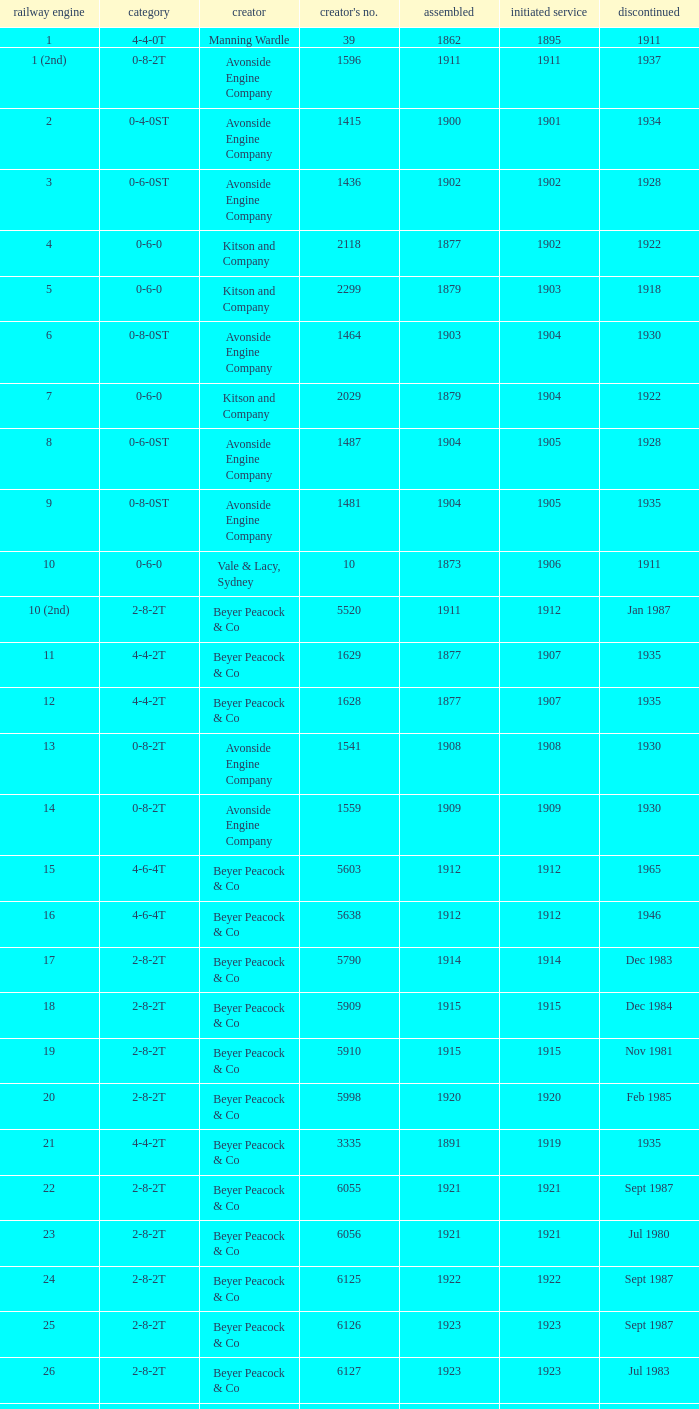How many years entered service when there were 13 locomotives? 1.0. Could you help me parse every detail presented in this table? {'header': ['railway engine', 'category', 'creator', "creator's no.", 'assembled', 'initiated service', 'discontinued'], 'rows': [['1', '4-4-0T', 'Manning Wardle', '39', '1862', '1895', '1911'], ['1 (2nd)', '0-8-2T', 'Avonside Engine Company', '1596', '1911', '1911', '1937'], ['2', '0-4-0ST', 'Avonside Engine Company', '1415', '1900', '1901', '1934'], ['3', '0-6-0ST', 'Avonside Engine Company', '1436', '1902', '1902', '1928'], ['4', '0-6-0', 'Kitson and Company', '2118', '1877', '1902', '1922'], ['5', '0-6-0', 'Kitson and Company', '2299', '1879', '1903', '1918'], ['6', '0-8-0ST', 'Avonside Engine Company', '1464', '1903', '1904', '1930'], ['7', '0-6-0', 'Kitson and Company', '2029', '1879', '1904', '1922'], ['8', '0-6-0ST', 'Avonside Engine Company', '1487', '1904', '1905', '1928'], ['9', '0-8-0ST', 'Avonside Engine Company', '1481', '1904', '1905', '1935'], ['10', '0-6-0', 'Vale & Lacy, Sydney', '10', '1873', '1906', '1911'], ['10 (2nd)', '2-8-2T', 'Beyer Peacock & Co', '5520', '1911', '1912', 'Jan 1987'], ['11', '4-4-2T', 'Beyer Peacock & Co', '1629', '1877', '1907', '1935'], ['12', '4-4-2T', 'Beyer Peacock & Co', '1628', '1877', '1907', '1935'], ['13', '0-8-2T', 'Avonside Engine Company', '1541', '1908', '1908', '1930'], ['14', '0-8-2T', 'Avonside Engine Company', '1559', '1909', '1909', '1930'], ['15', '4-6-4T', 'Beyer Peacock & Co', '5603', '1912', '1912', '1965'], ['16', '4-6-4T', 'Beyer Peacock & Co', '5638', '1912', '1912', '1946'], ['17', '2-8-2T', 'Beyer Peacock & Co', '5790', '1914', '1914', 'Dec 1983'], ['18', '2-8-2T', 'Beyer Peacock & Co', '5909', '1915', '1915', 'Dec 1984'], ['19', '2-8-2T', 'Beyer Peacock & Co', '5910', '1915', '1915', 'Nov 1981'], ['20', '2-8-2T', 'Beyer Peacock & Co', '5998', '1920', '1920', 'Feb 1985'], ['21', '4-4-2T', 'Beyer Peacock & Co', '3335', '1891', '1919', '1935'], ['22', '2-8-2T', 'Beyer Peacock & Co', '6055', '1921', '1921', 'Sept 1987'], ['23', '2-8-2T', 'Beyer Peacock & Co', '6056', '1921', '1921', 'Jul 1980'], ['24', '2-8-2T', 'Beyer Peacock & Co', '6125', '1922', '1922', 'Sept 1987'], ['25', '2-8-2T', 'Beyer Peacock & Co', '6126', '1923', '1923', 'Sept 1987'], ['26', '2-8-2T', 'Beyer Peacock & Co', '6127', '1923', '1923', 'Jul 1983'], ['27', '2-8-2T', 'Beyer Peacock & Co', '6137', '1923', '1923', 'Mar 1987'], ['28', '2-8-2T', 'Beyer Peacock & Co', '6138', '1923', '1923', 'Dec 1983'], ['29', '4-6-4T', 'Beyer Peacock & Co', '6139', '1923', '1923', '1965'], ['30', '2-8-2T', 'Beyer Peacock & Co', '6294', '1926', '1926', 'Sept 1987'], ['31', '2-8-2T', 'Beyer Peacock & Co', '5295', '1926', '1926', 'Jun 1984']]} 